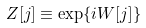Convert formula to latex. <formula><loc_0><loc_0><loc_500><loc_500>Z [ j ] \equiv \exp \{ i W [ j ] \}</formula> 